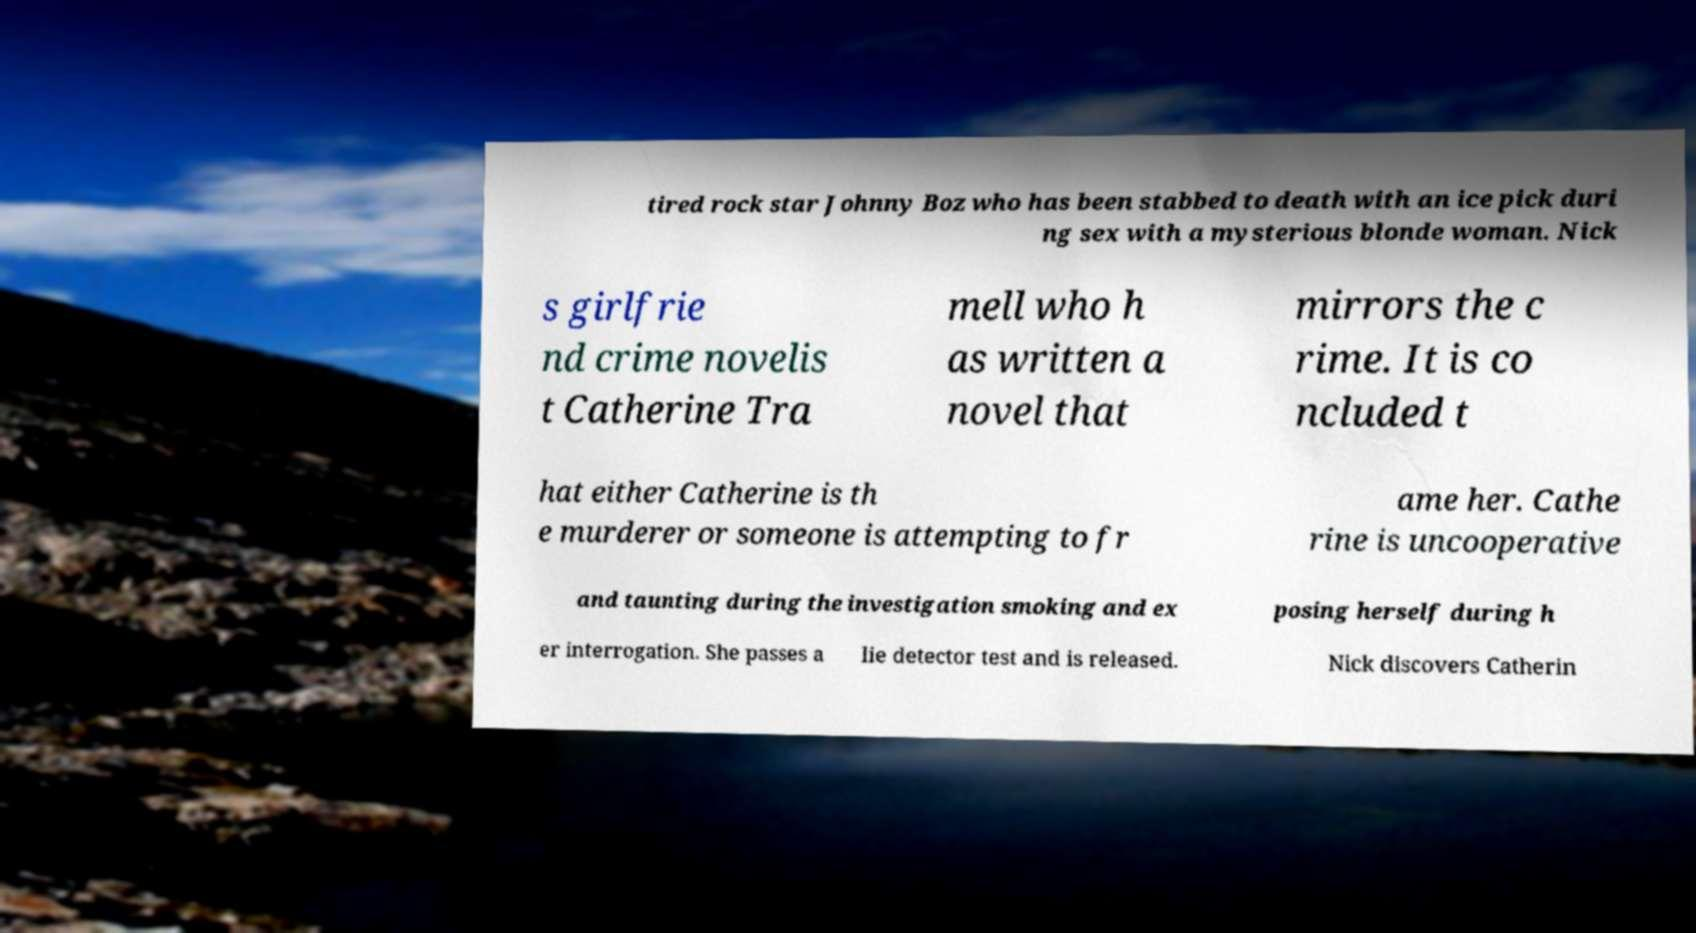Please read and relay the text visible in this image. What does it say? tired rock star Johnny Boz who has been stabbed to death with an ice pick duri ng sex with a mysterious blonde woman. Nick s girlfrie nd crime novelis t Catherine Tra mell who h as written a novel that mirrors the c rime. It is co ncluded t hat either Catherine is th e murderer or someone is attempting to fr ame her. Cathe rine is uncooperative and taunting during the investigation smoking and ex posing herself during h er interrogation. She passes a lie detector test and is released. Nick discovers Catherin 